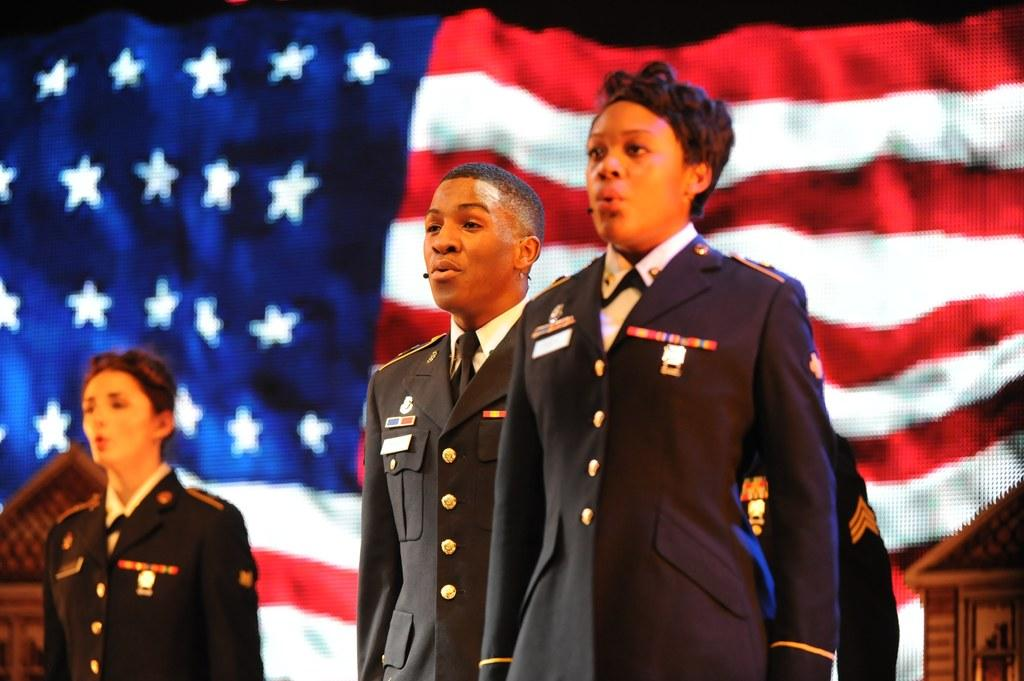What is happening in the image? There are people standing in the image. What can be seen in the background of the image? There is a flag in the background of the image. What type of curve can be seen in the image? There is no curve present in the image. What wall is visible in the image? There is no wall visible in the image. 